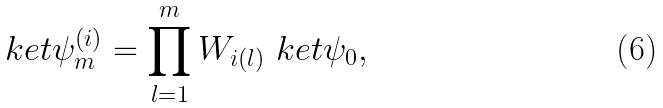<formula> <loc_0><loc_0><loc_500><loc_500>\ k e t { \psi ^ { ( i ) } _ { m } } = \prod _ { l = 1 } ^ { m } W _ { i ( l ) } \ k e t { \psi _ { 0 } } ,</formula> 